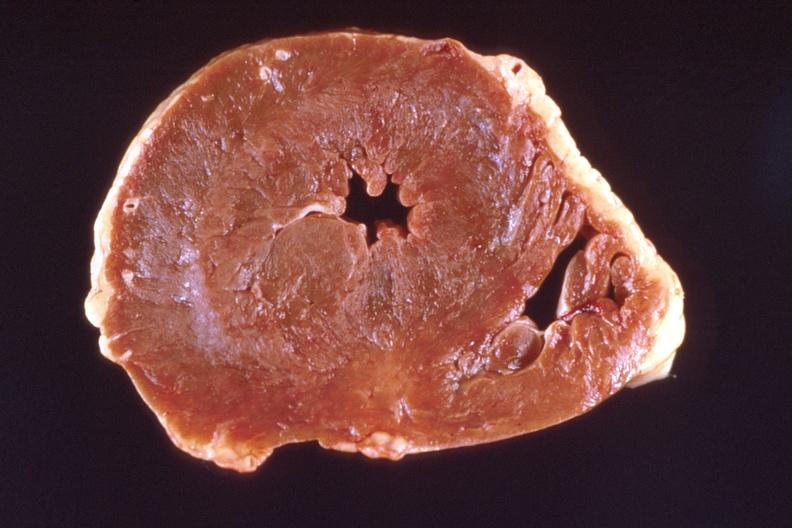what left ventricular hypertrophy?
Answer the question using a single word or phrase. Marked 